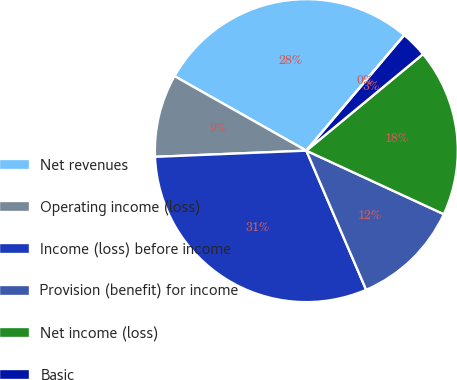Convert chart. <chart><loc_0><loc_0><loc_500><loc_500><pie_chart><fcel>Net revenues<fcel>Operating income (loss)<fcel>Income (loss) before income<fcel>Provision (benefit) for income<fcel>Net income (loss)<fcel>Basic<fcel>Diluted<nl><fcel>28.0%<fcel>8.84%<fcel>30.81%<fcel>11.65%<fcel>17.89%<fcel>2.81%<fcel>0.0%<nl></chart> 